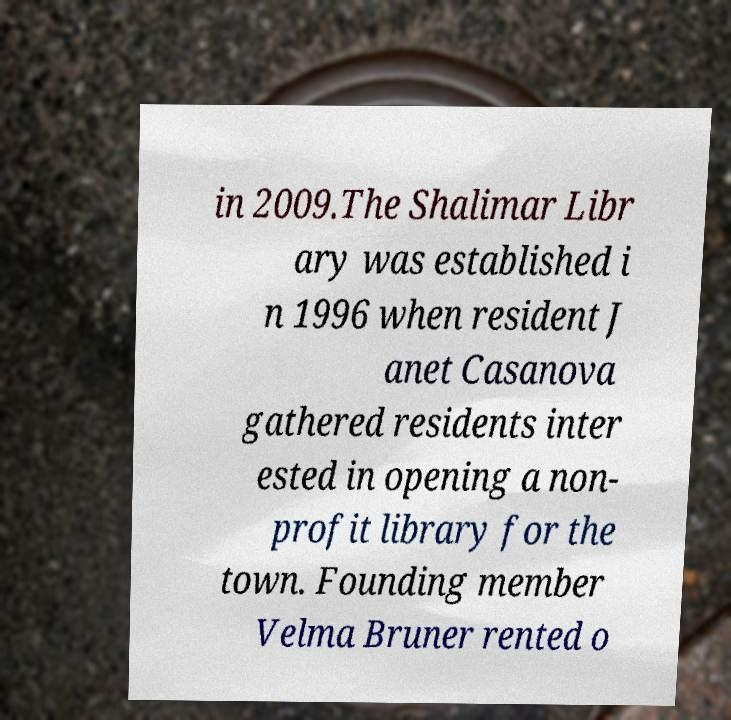For documentation purposes, I need the text within this image transcribed. Could you provide that? in 2009.The Shalimar Libr ary was established i n 1996 when resident J anet Casanova gathered residents inter ested in opening a non- profit library for the town. Founding member Velma Bruner rented o 